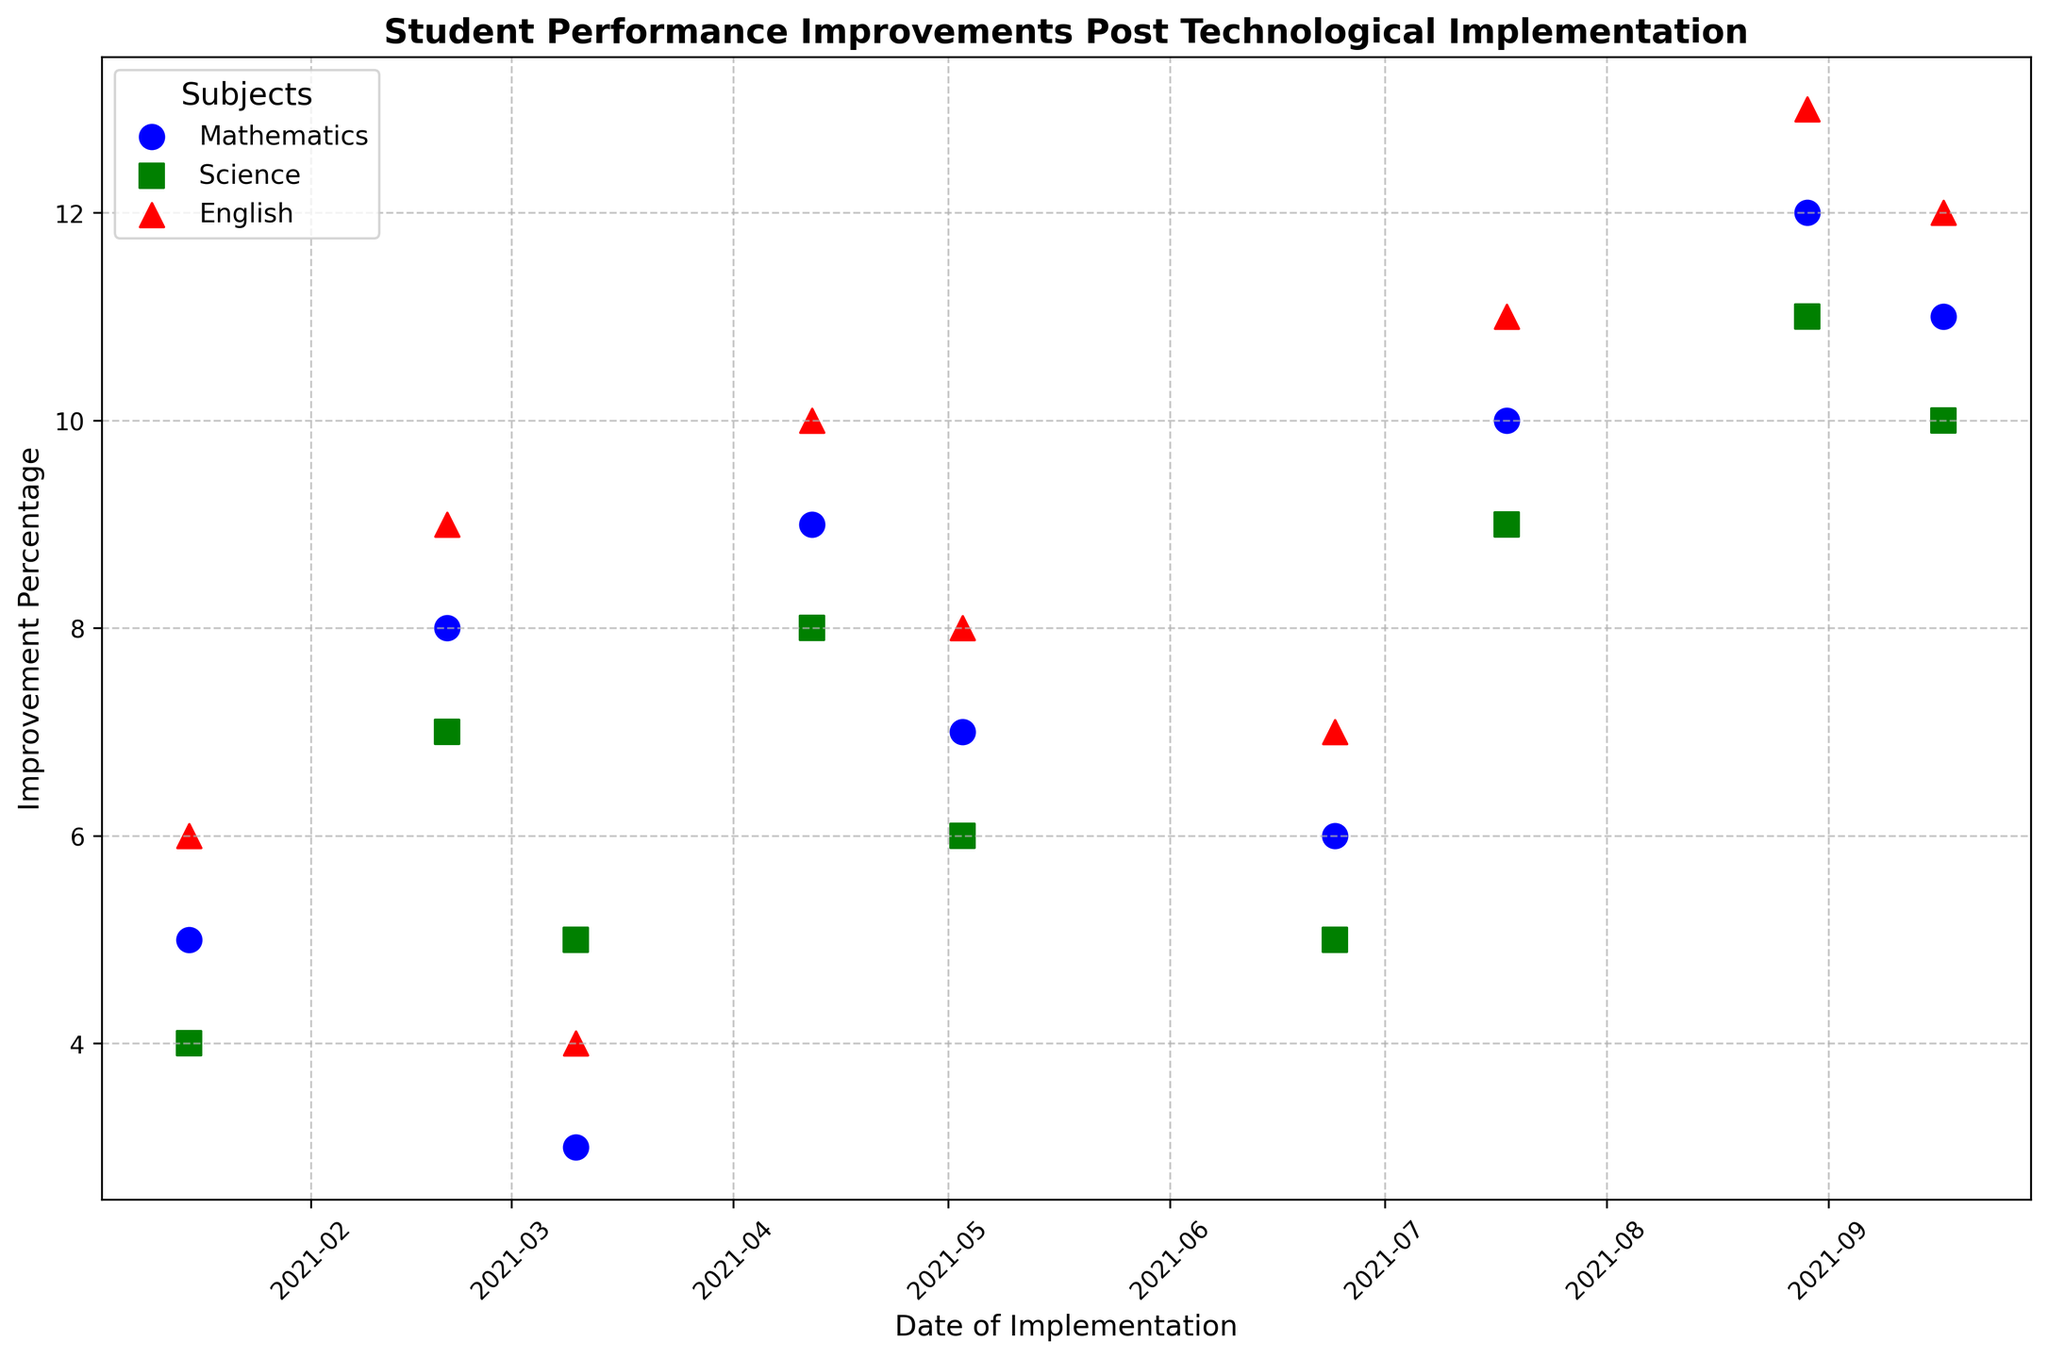Which subject showed the highest improvement percentage in August 2021? To find the highest improvement in a specific month, locate the August 2021 data points and compare the improvement percentages for Mathematics, Science, and English.
Answer: English Comparing Mathematics improvements in January and September, which month had a higher percentage? Locate the improvement percentages for Mathematics in January and September and compare them. January has 5%, and September has 11%.
Answer: September What is the difference in improvement percentage between Science and English in July 2021? Look at the data points for July 2021 and locate the improvement percentages for Science and English. Subtract the Science percentage (9%) from the English percentage (11%).
Answer: 2% On which date did Mathematics show the highest improvement percentage, and what was the percentage? To find the highest improvement percentage for Mathematics, scan through all dates and locate the maximum value. The highest improvement for Mathematics is 12% on August 29, 2021.
Answer: August 29, 2021, 12% Which subject had the most consistent improvement in percentages across all dates, and how would you describe the trend visually? Visually examine the data points for each subject across all dates. Science has the most consistent improvements, showing incremental increases without large fluctuations.
Answer: Science Which subject had the steepest improvement between any two consecutive months, and what were the percentages? Look for the largest increase between any two consecutive data points for each subject. For Mathematics, locate the dates and values: the most significant increase is from 7% on July 18, 2021, to 12% on August 29, 2021.
Answer: Mathematics (7% to 12%) What is the average improvement percentage for English across all dates? Sum all the improvement percentages for English and divide by the number of data points (6+9+4+10+8+7+11+13+12). The sum is 80, and there are 9 data points, so the average is 80/9.
Answer: 8.89 How does the improvement percentage for Science in April compare to that in June? Look at the data points for Science in April and June. In April, the percentage is 8%, and in June, it is 5%, showing a decrease.
Answer: April is higher Which date shows the lowest improvement for Mathematics, and what is the percentage? Identify the lowest improvement percentage for Mathematics by scanning through all the data points and selecting the minimum value. The lowest percentage is 3% on March 10, 2021.
Answer: March 10, 2021, 3% Calculate the total improvement in percentages for all subjects combined in May 2021. Add up the improvement percentages for Mathematics, Science, and English in May 2021 (7+6+8). The sum of these values gives the total improvement.
Answer: 21 